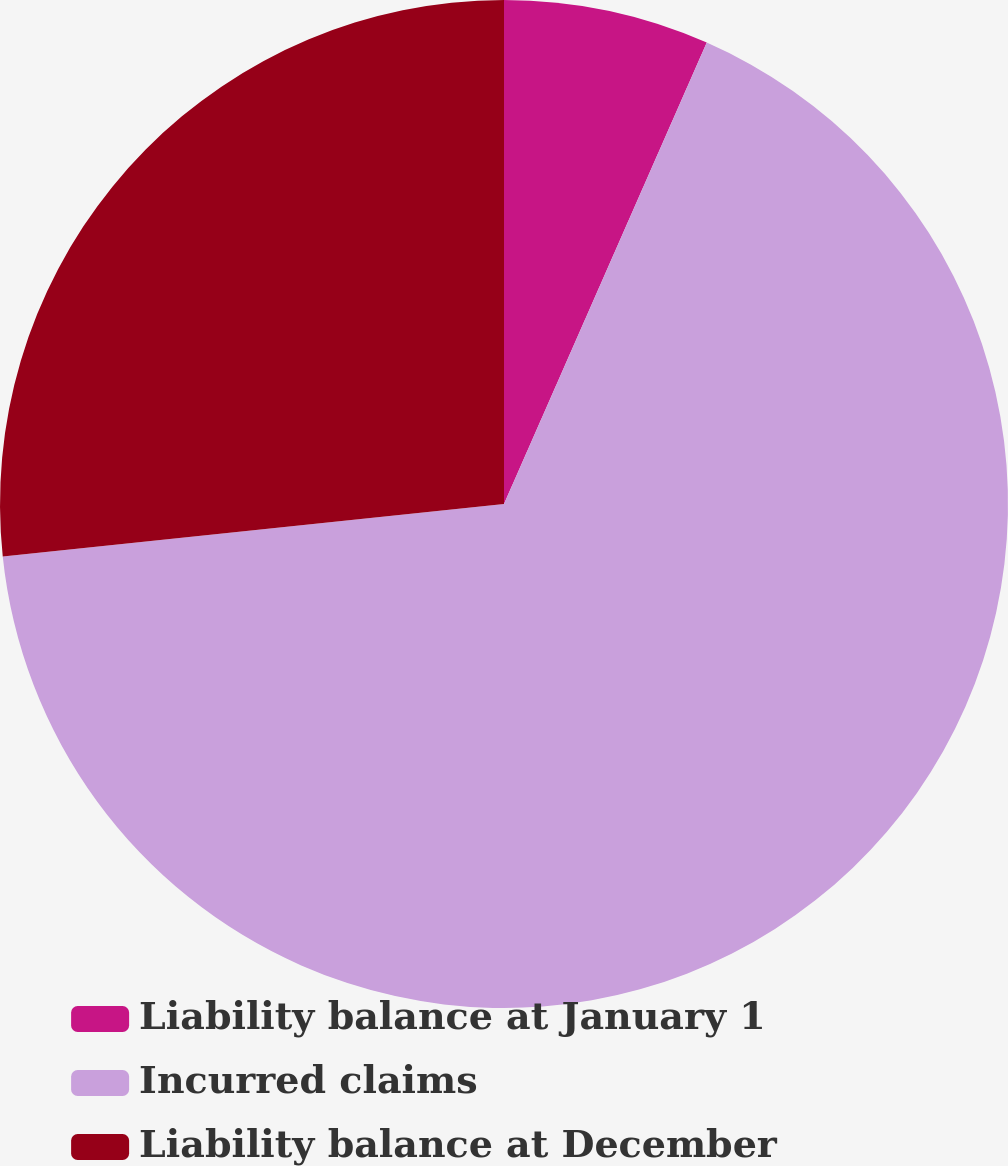<chart> <loc_0><loc_0><loc_500><loc_500><pie_chart><fcel>Liability balance at January 1<fcel>Incurred claims<fcel>Liability balance at December<nl><fcel>6.59%<fcel>66.75%<fcel>26.66%<nl></chart> 